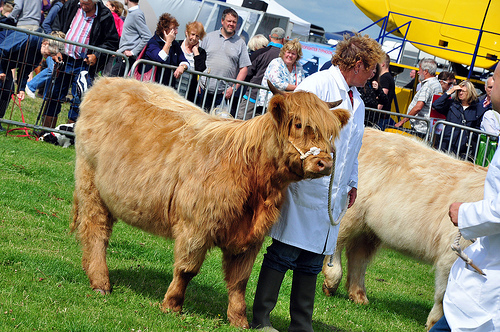<image>
Can you confirm if the bull is on the woman? No. The bull is not positioned on the woman. They may be near each other, but the bull is not supported by or resting on top of the woman. 